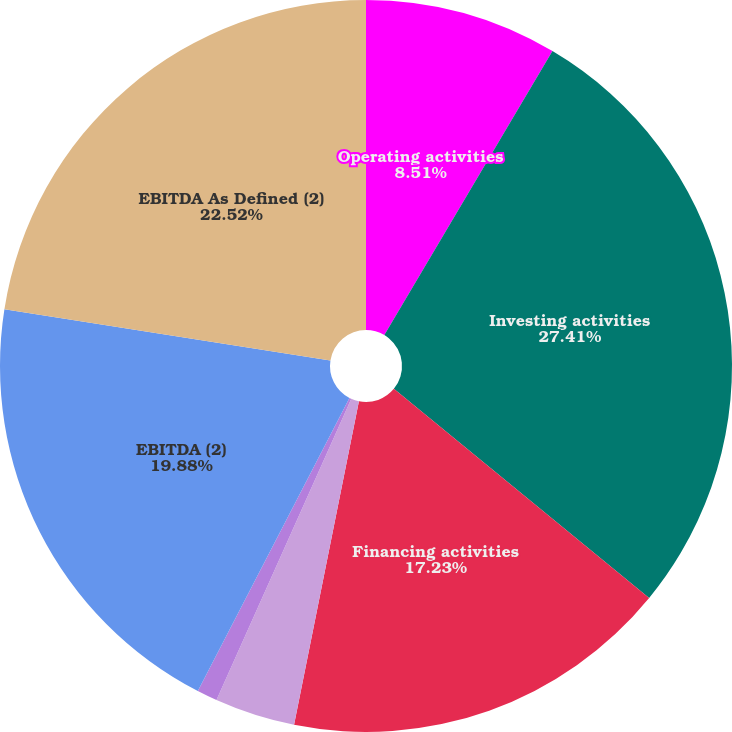<chart> <loc_0><loc_0><loc_500><loc_500><pie_chart><fcel>Operating activities<fcel>Investing activities<fcel>Financing activities<fcel>Depreciation and amortization<fcel>Capital expenditures<fcel>EBITDA (2)<fcel>EBITDA As Defined (2)<nl><fcel>8.51%<fcel>27.42%<fcel>17.23%<fcel>3.55%<fcel>0.9%<fcel>19.88%<fcel>22.53%<nl></chart> 